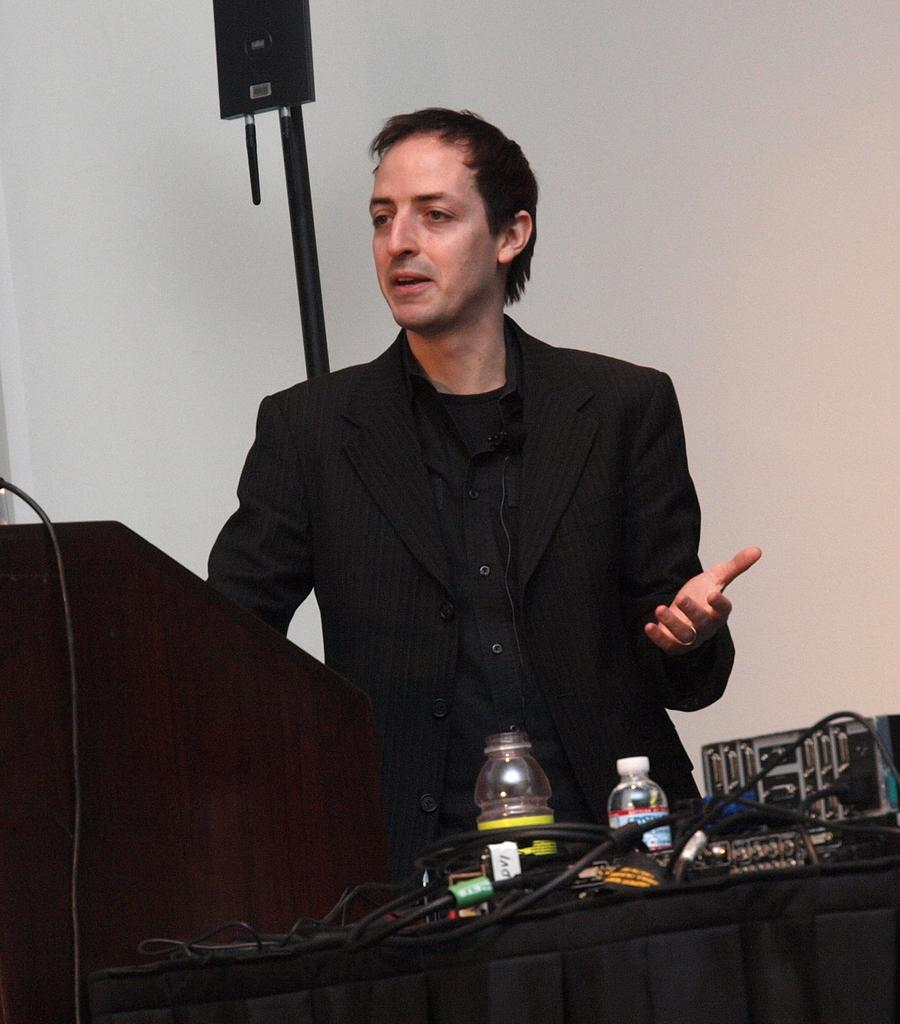Who is present in the image? There is a man in the image. What is the man wearing? The man is wearing a suit. What objects can be seen in the image besides the man? There are bottles and cables in the image. What type of background is visible in the image? There is a wall in the image. What color is the cherry on the man's scarf in the image? There is no cherry or scarf present in the image. What type of machine is being used by the man in the image? There is no machine visible in the image; the man is not performing any actions. 